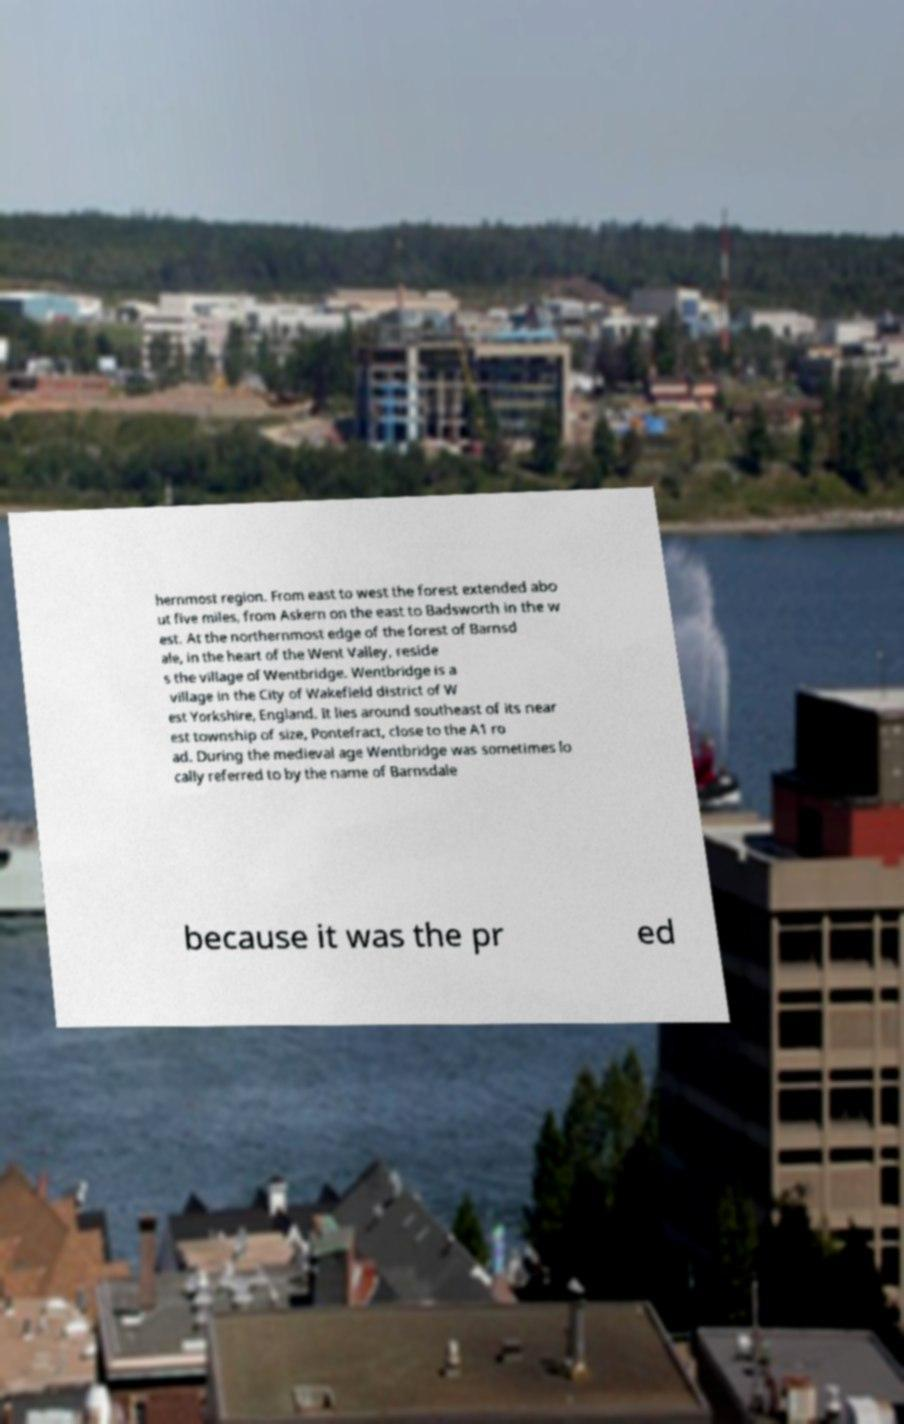Can you accurately transcribe the text from the provided image for me? hernmost region. From east to west the forest extended abo ut five miles, from Askern on the east to Badsworth in the w est. At the northernmost edge of the forest of Barnsd ale, in the heart of the Went Valley, reside s the village of Wentbridge. Wentbridge is a village in the City of Wakefield district of W est Yorkshire, England. It lies around southeast of its near est township of size, Pontefract, close to the A1 ro ad. During the medieval age Wentbridge was sometimes lo cally referred to by the name of Barnsdale because it was the pr ed 